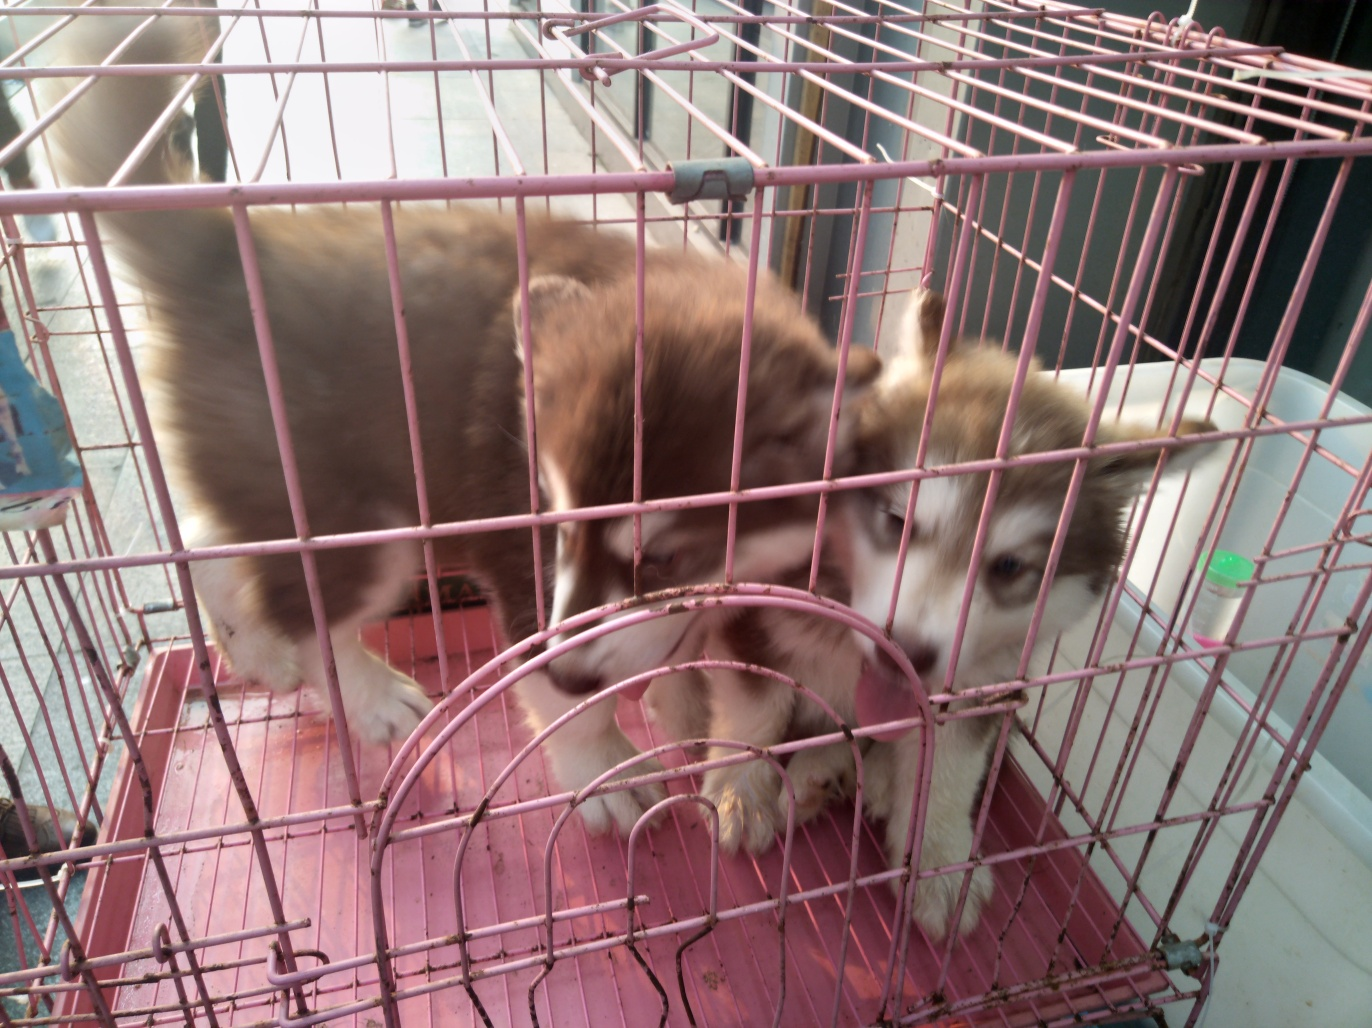What breed of dogs are shown in this image? The dogs in the image resemble the Siberian Husky breed, known for their thick fur coat, erect triangular ears, and distinctive markings. 